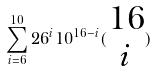Convert formula to latex. <formula><loc_0><loc_0><loc_500><loc_500>\sum _ { i = 6 } ^ { 1 0 } 2 6 ^ { i } 1 0 ^ { 1 6 - i } ( \begin{matrix} 1 6 \\ i \end{matrix} )</formula> 